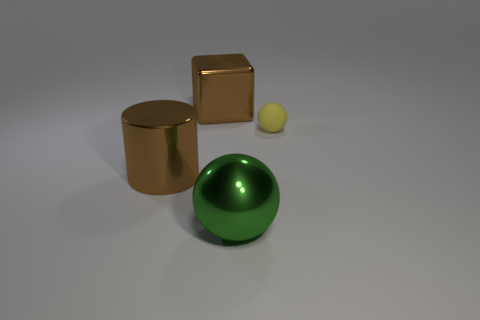Add 2 cylinders. How many objects exist? 6 Subtract all green spheres. How many spheres are left? 1 Subtract all cylinders. How many objects are left? 3 Subtract 1 spheres. How many spheres are left? 1 Add 2 metal things. How many metal things exist? 5 Subtract 0 red balls. How many objects are left? 4 Subtract all gray spheres. Subtract all yellow cubes. How many spheres are left? 2 Subtract all red cylinders. How many green balls are left? 1 Subtract all large brown things. Subtract all large brown objects. How many objects are left? 0 Add 2 matte objects. How many matte objects are left? 3 